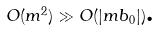<formula> <loc_0><loc_0><loc_500><loc_500>O ( m ^ { 2 } ) \gg O ( \left | m b _ { 0 } \right | ) \text {.}</formula> 